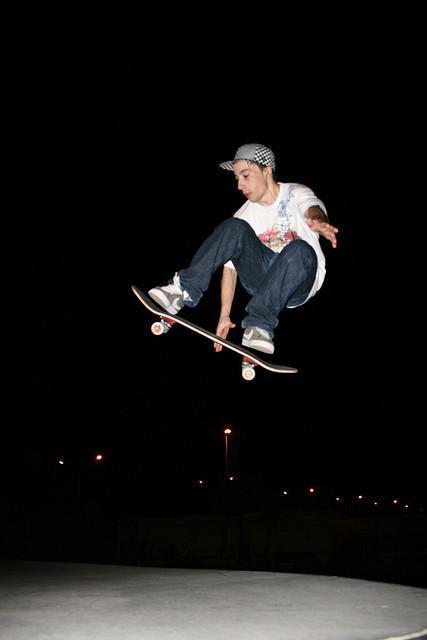How many wheels are not touching the ground?
Give a very brief answer. 4. How many of the man's feet are on the board?
Give a very brief answer. 2. 